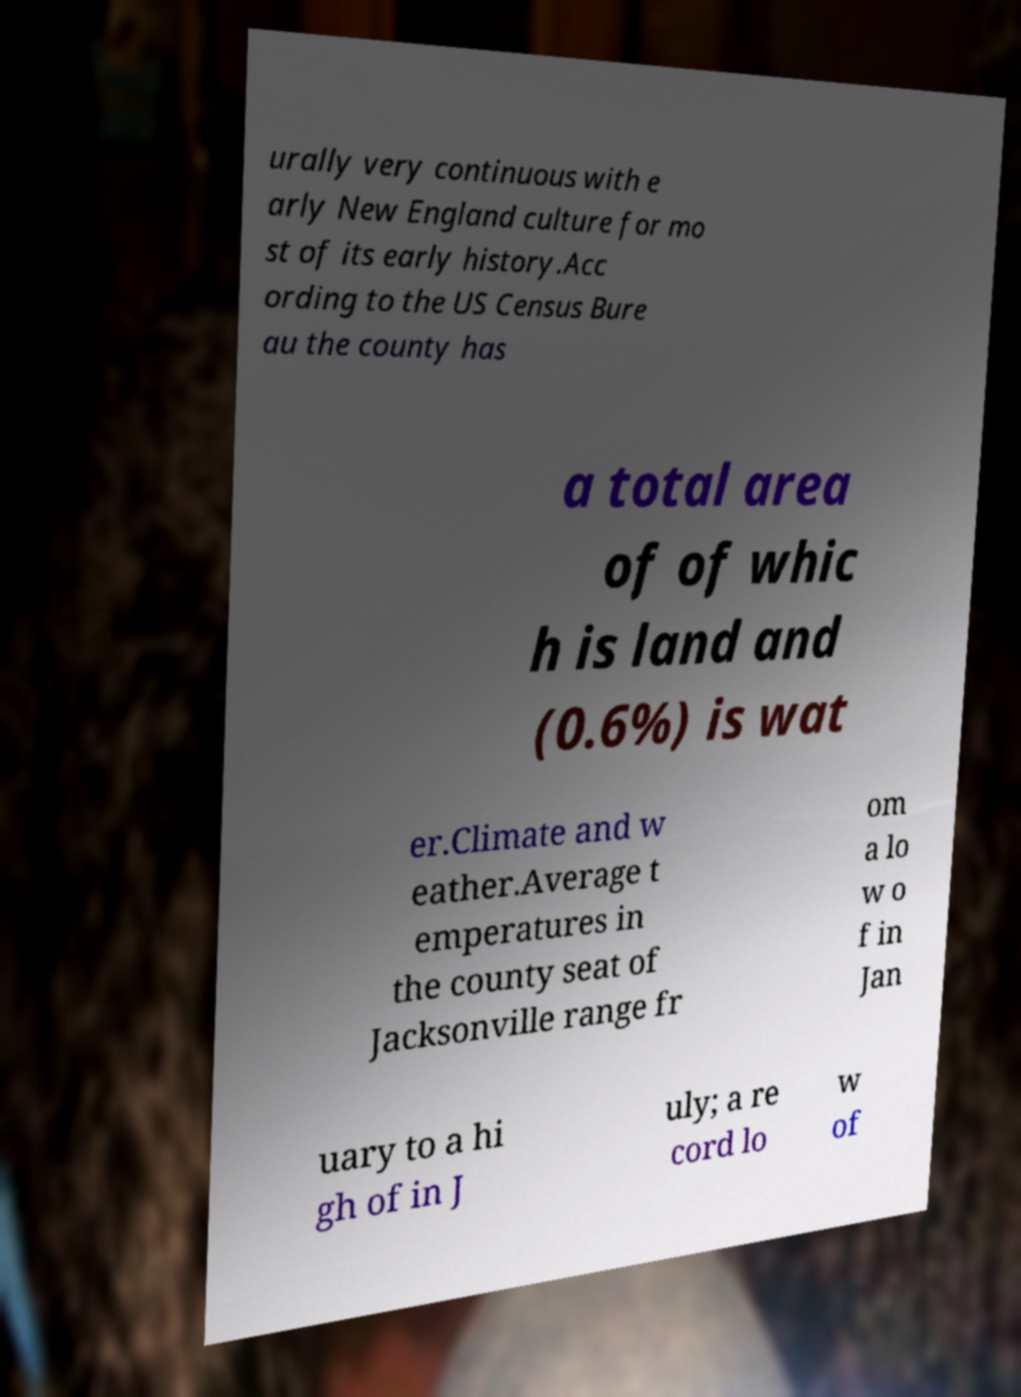Could you extract and type out the text from this image? urally very continuous with e arly New England culture for mo st of its early history.Acc ording to the US Census Bure au the county has a total area of of whic h is land and (0.6%) is wat er.Climate and w eather.Average t emperatures in the county seat of Jacksonville range fr om a lo w o f in Jan uary to a hi gh of in J uly; a re cord lo w of 